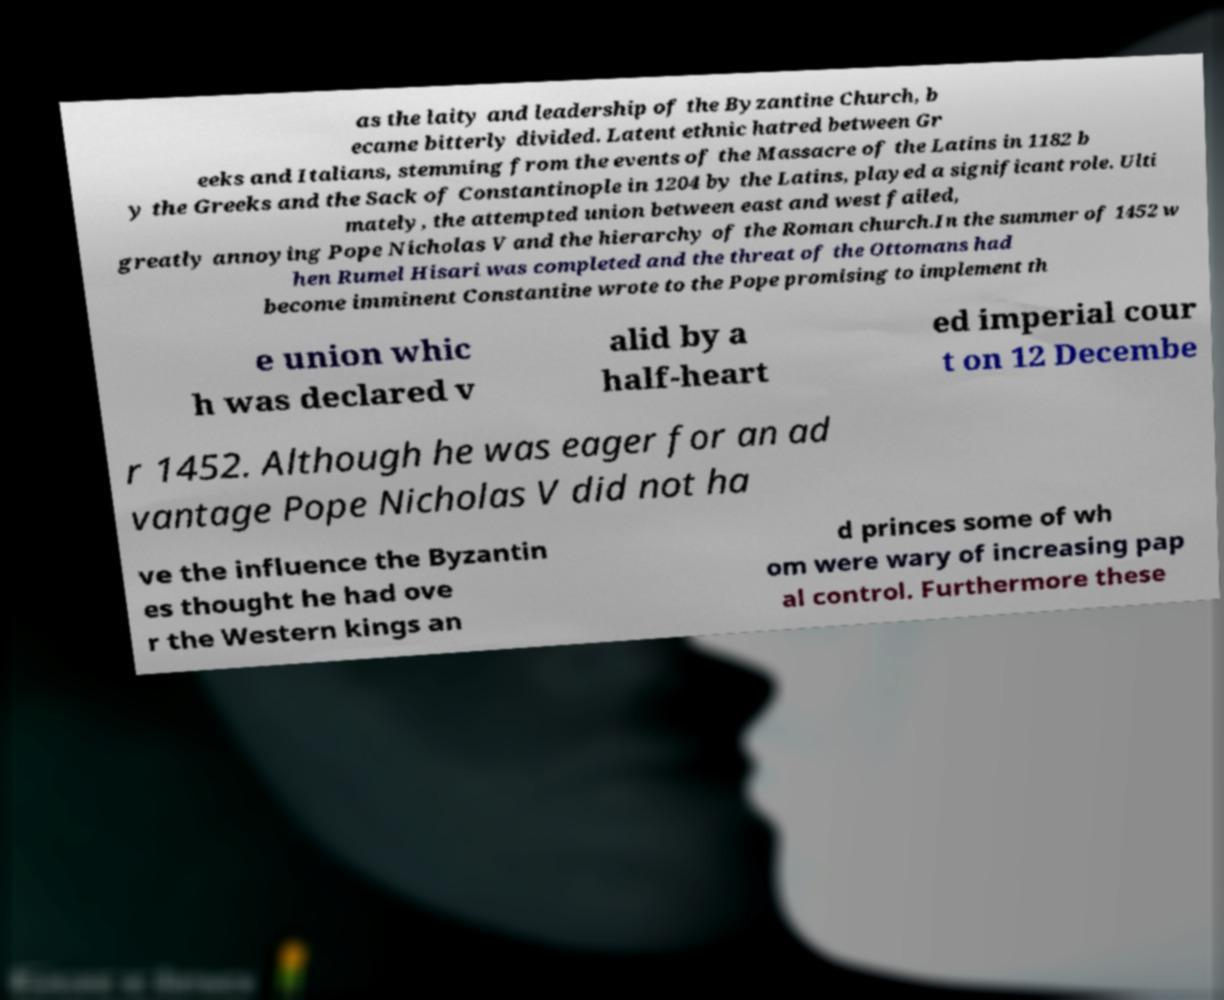What messages or text are displayed in this image? I need them in a readable, typed format. as the laity and leadership of the Byzantine Church, b ecame bitterly divided. Latent ethnic hatred between Gr eeks and Italians, stemming from the events of the Massacre of the Latins in 1182 b y the Greeks and the Sack of Constantinople in 1204 by the Latins, played a significant role. Ulti mately, the attempted union between east and west failed, greatly annoying Pope Nicholas V and the hierarchy of the Roman church.In the summer of 1452 w hen Rumel Hisari was completed and the threat of the Ottomans had become imminent Constantine wrote to the Pope promising to implement th e union whic h was declared v alid by a half-heart ed imperial cour t on 12 Decembe r 1452. Although he was eager for an ad vantage Pope Nicholas V did not ha ve the influence the Byzantin es thought he had ove r the Western kings an d princes some of wh om were wary of increasing pap al control. Furthermore these 